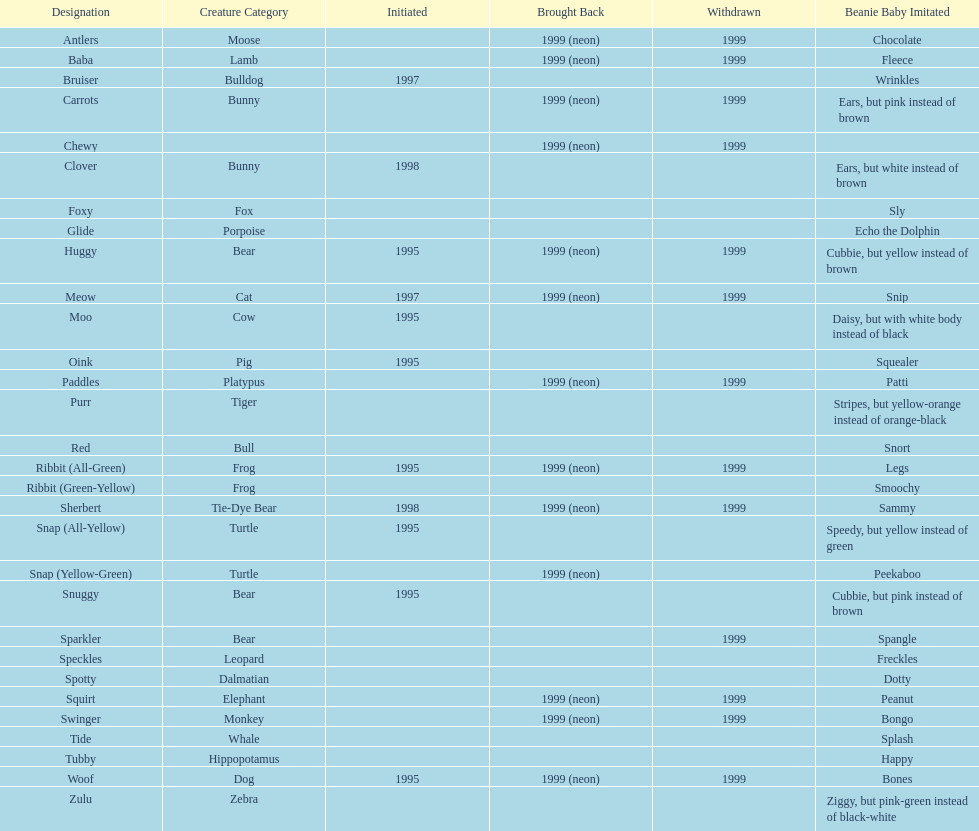What are the total number of pillow pals on this chart? 30. 